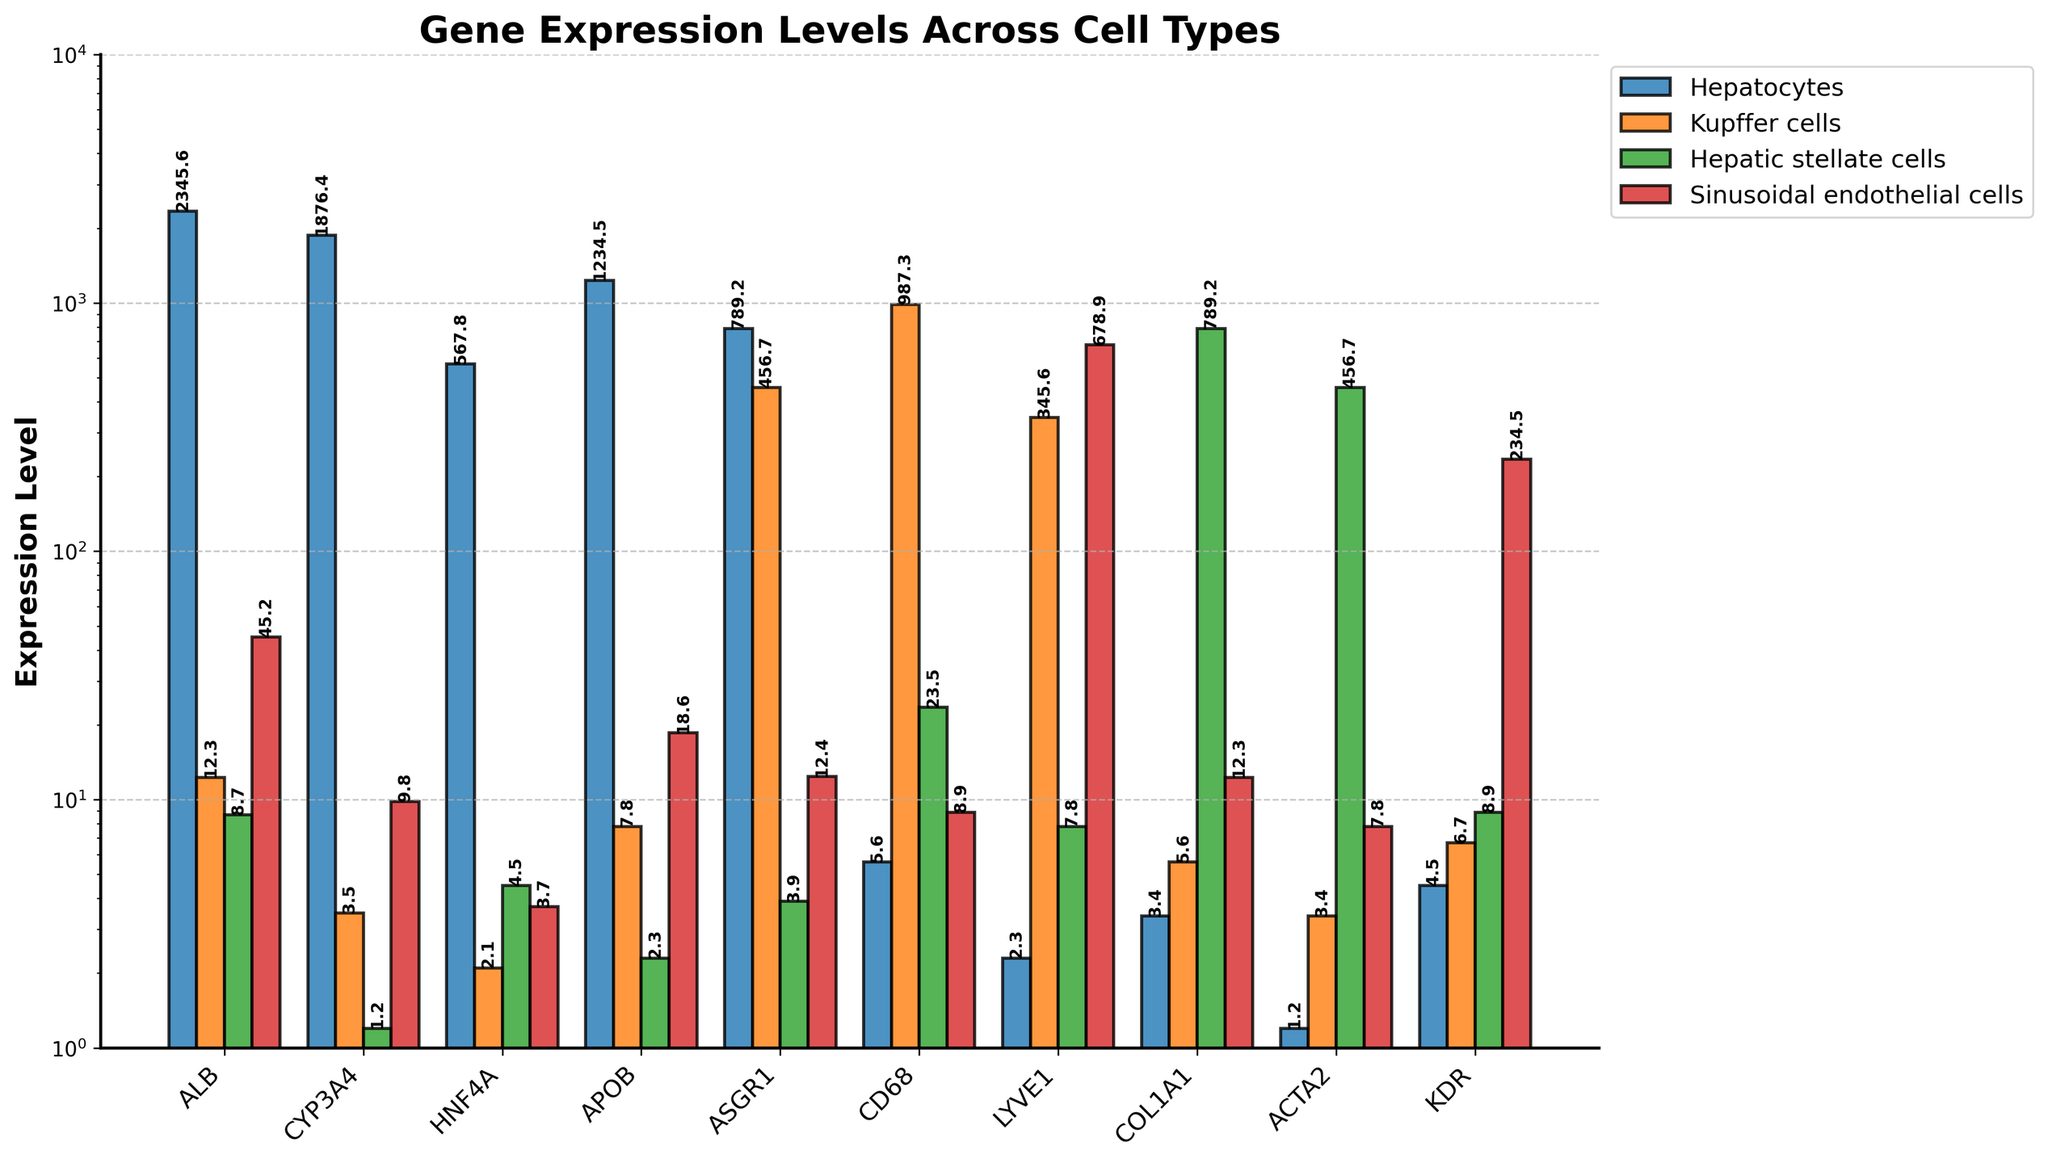What's the gene with the highest expression level in Kupffer cells? To find this, we compare the heights of the bars for Kupffer cells. CD68 has the highest bar.
Answer: CD68 How does the expression level of ALB in Hepatocytes compare to Sinusoidal endothelial cells? Look at the bar heights for ALB in both cell types. ALB in Hepatocytes has a much higher bar than in Sinusoidal endothelial cells.
Answer: Higher What is the difference in expression levels of LYVE1 between Kupffer cells and Sinusoidal endothelial cells? LYVE1 in Kupffer cells is 345.6 and in Sinusoidal endothelial cells is 678.9. The difference is 678.9 - 345.6.
Answer: 333.3 Which gene shows the greatest variation in expression levels across all cell types? By comparing the range of expression levels for each gene across all cell types, LYVE1 varies from 2.3 to 678.9, the largest range.
Answer: LYVE1 What is the average expression level of APOB across all cell types? Add the expression levels of APOB (1234.5, 7.8, 2.3, 18.6) and divide by 4. The average is (1234.5 + 7.8 + 2.3 + 18.6) / 4.
Answer: 315.8 Which cell type has the lowest expression level for ACTA2? Compare the bar heights for ACTA2 across all cell types. Hepatocytes has the shortest bar.
Answer: Hepatocytes How many genes have an expression level greater than 1000 in Hepatocytes? Identify and count the bars in Hepatocytes that are taller than the bar representing 1000. ALB and CYP3A4 exceed 1000.
Answer: 2 Is the expression level of COL1A1 in Hepatic stellate cells closer to Kupffer cells or Sinusoidal endothelial cells? Compare the bars for COL1A1 in Kupffer cells (5.6) and Sinusoidal endothelial cells (12.3). COL1A1 in Hepatic stellate cells is 789.2. The difference between 789.2 and 5.6 (783.6) is greater than between 789.2 and 12.3 (776.9).
Answer: Sinusoidal endothelial cells What is the sum of the expression levels of KDR in all cell types? Add the KDR levels across all cell types (4.5, 6.7, 8.9, 234.5). The sum is (4.5 + 6.7 + 8.9 + 234.5).
Answer: 254.6 How does the expression level of ASGR1 in Kupffer cells compare to its level in Hepatic stellate cells? Compare the bar heights for ASGR1 in Kupffer cells (456.7) and Hepatic stellate cells (3.9). ASGR1 in Kupffer cells is significantly higher.
Answer: Higher 